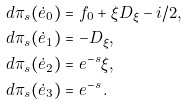Convert formula to latex. <formula><loc_0><loc_0><loc_500><loc_500>d \pi _ { s } ( \dot { e } _ { 0 } ) & = f _ { 0 } + \xi D _ { \xi } - i / 2 , \\ d \pi _ { s } ( \dot { e } _ { 1 } ) & = - D _ { \xi } , \\ d \pi _ { s } ( \dot { e } _ { 2 } ) & = e ^ { - s } \xi , \\ d \pi _ { s } ( \dot { e } _ { 3 } ) & = e ^ { - s } \, .</formula> 